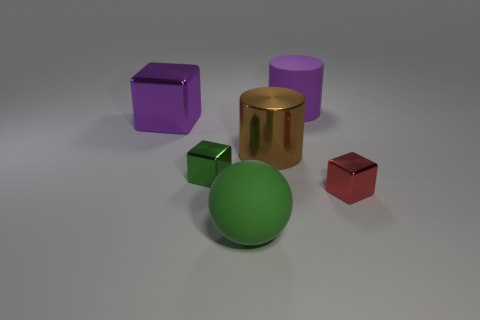How many small purple matte cubes are there?
Provide a short and direct response. 0. There is a big cylinder that is in front of the cylinder that is behind the large brown thing on the left side of the large rubber cylinder; what is its material?
Your response must be concise. Metal. Is there a big purple object that has the same material as the purple block?
Ensure brevity in your answer.  No. Do the large purple cube and the small red block have the same material?
Your answer should be very brief. Yes. What number of cylinders are yellow things or large green rubber things?
Your response must be concise. 0. The thing that is made of the same material as the green ball is what color?
Ensure brevity in your answer.  Purple. Is the number of red objects less than the number of big things?
Your answer should be compact. Yes. There is a big purple thing on the right side of the large green object; is its shape the same as the rubber thing in front of the green metal thing?
Your answer should be compact. No. What number of things are either big purple objects or small matte cubes?
Make the answer very short. 2. What color is the shiny cylinder that is the same size as the matte cylinder?
Offer a terse response. Brown. 